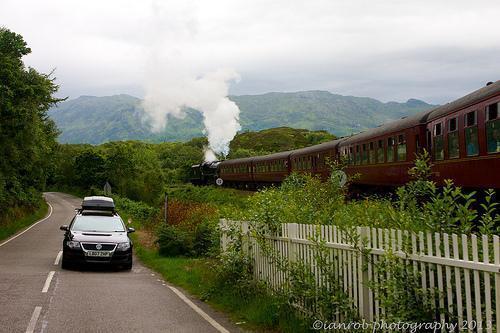How many cars are pictured?
Give a very brief answer. 1. 